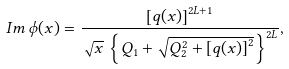<formula> <loc_0><loc_0><loc_500><loc_500>I m \, \phi ( x ) = \frac { \left [ q ( x ) \right ] ^ { 2 L + 1 } } { \sqrt { x } \, \left \{ Q _ { 1 } + \sqrt { Q _ { 2 } ^ { 2 } + \left [ q ( x ) \right ] ^ { 2 } } \right \} ^ { 2 L } } ,</formula> 